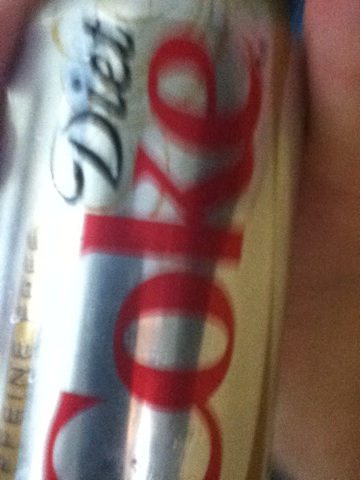what kind of soda is this please you guys are doing a great job. from Vizwiz diet coke 